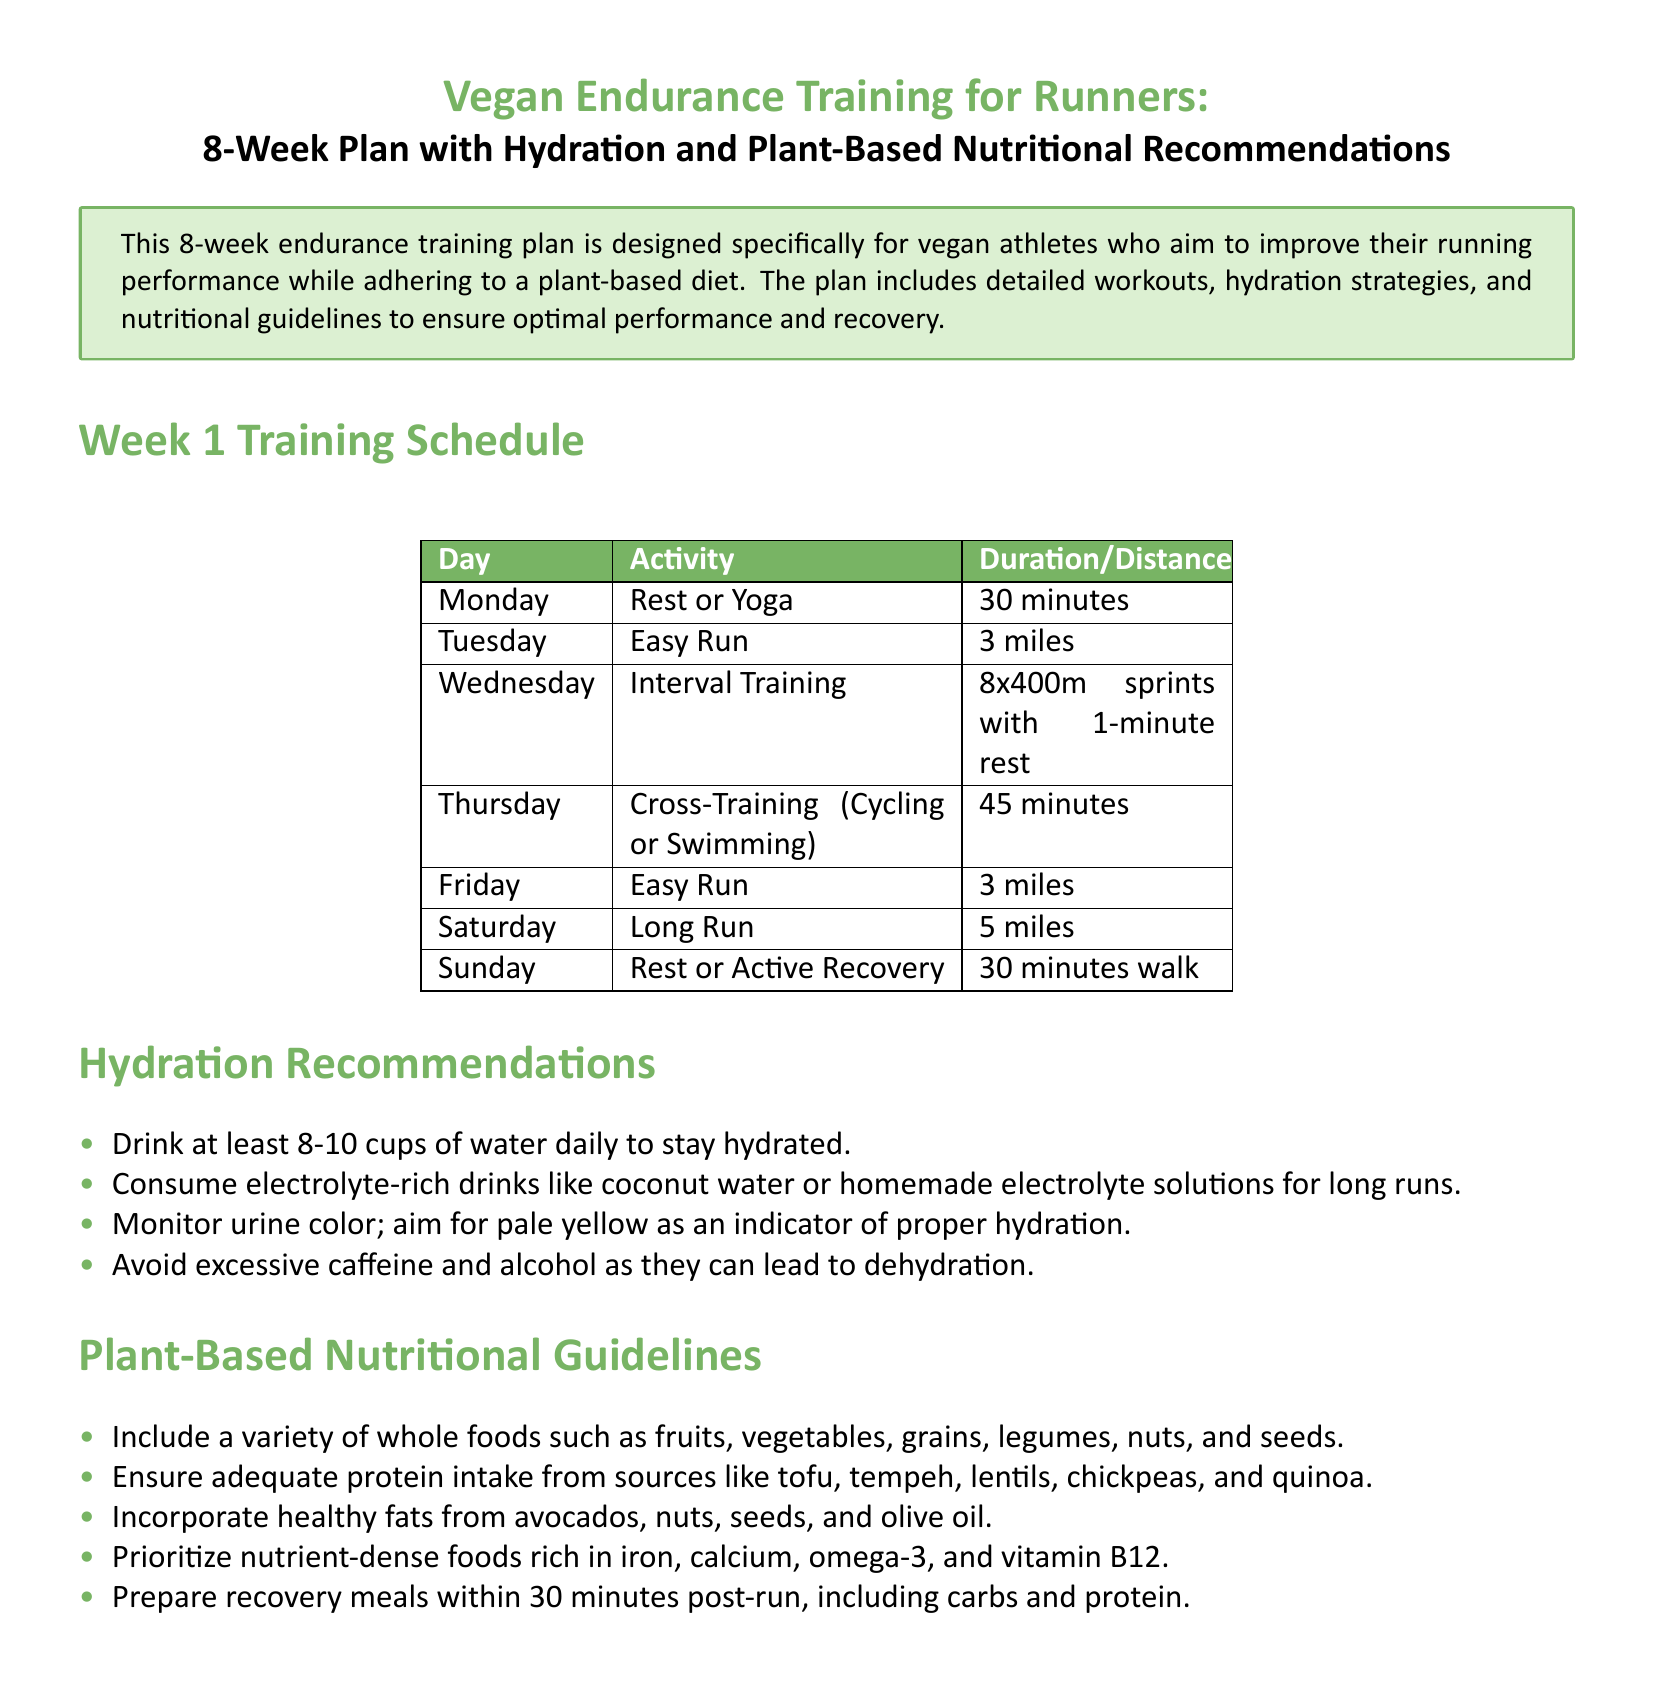What is the duration of the easy run on Tuesday? The duration is specified in the training schedule for Tuesday under activity "Easy Run".
Answer: 3 miles How many times do runners sprint during interval training? The number of sprints in the interval training is listed under Wednesday's activity.
Answer: 8x400m sprints What is recommended for hydration during long runs? The document specifies that for long runs, runners should consume electrolyte-rich drinks.
Answer: Electrolyte-rich drinks Which day is designated for rest or active recovery? The document lists Sunday as the day for rest or active recovery in the training schedule.
Answer: Sunday What type of fats are recommended in the nutritional guidelines? The document mentions healthy fats specifically as part of the plant-based nutritional guidelines.
Answer: Healthy fats What is suggested to monitor for hydration? The document advises monitoring urine color as an indicator of hydration.
Answer: Urine color How long should one wait to prepare recovery meals post-run? The preparation time for recovery meals is mentioned in the plant-based nutritional guidelines.
Answer: 30 minutes What type of training occurs on Thursdays? The activity scheduled for Thursday is described in the training schedule and is a different form of exercise.
Answer: Cross-Training 